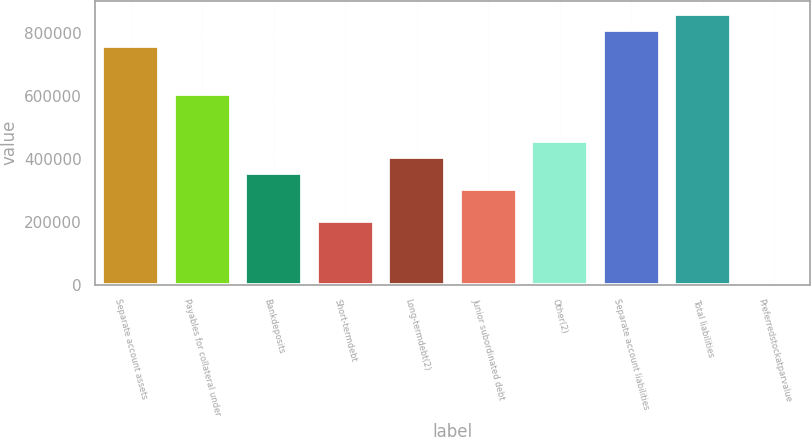Convert chart. <chart><loc_0><loc_0><loc_500><loc_500><bar_chart><fcel>Separate account assets<fcel>Payables for collateral under<fcel>Bankdeposits<fcel>Short-termdebt<fcel>Long-termdebt(2)<fcel>Junior subordinated debt<fcel>Other(2)<fcel>Separate account liabilities<fcel>Total liabilities<fcel>Preferredstockatparvalue<nl><fcel>758724<fcel>606979<fcel>354072<fcel>202327<fcel>404653<fcel>303490<fcel>455234<fcel>809305<fcel>859886<fcel>1<nl></chart> 